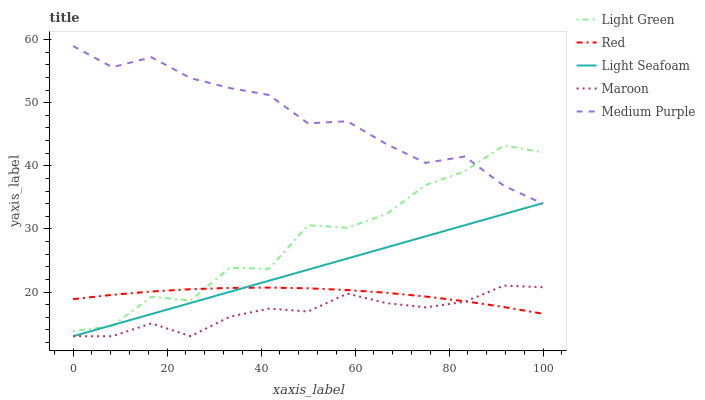Does Maroon have the minimum area under the curve?
Answer yes or no. Yes. Does Medium Purple have the maximum area under the curve?
Answer yes or no. Yes. Does Light Seafoam have the minimum area under the curve?
Answer yes or no. No. Does Light Seafoam have the maximum area under the curve?
Answer yes or no. No. Is Light Seafoam the smoothest?
Answer yes or no. Yes. Is Light Green the roughest?
Answer yes or no. Yes. Is Maroon the smoothest?
Answer yes or no. No. Is Maroon the roughest?
Answer yes or no. No. Does Red have the lowest value?
Answer yes or no. No. Does Medium Purple have the highest value?
Answer yes or no. Yes. Does Maroon have the highest value?
Answer yes or no. No. Is Maroon less than Light Green?
Answer yes or no. Yes. Is Medium Purple greater than Red?
Answer yes or no. Yes. Does Maroon intersect Red?
Answer yes or no. Yes. Is Maroon less than Red?
Answer yes or no. No. Is Maroon greater than Red?
Answer yes or no. No. Does Maroon intersect Light Green?
Answer yes or no. No. 